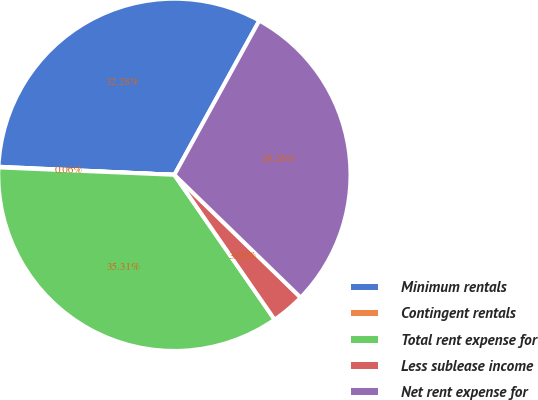<chart> <loc_0><loc_0><loc_500><loc_500><pie_chart><fcel>Minimum rentals<fcel>Contingent rentals<fcel>Total rent expense for<fcel>Less sublease income<fcel>Net rent expense for<nl><fcel>32.28%<fcel>0.06%<fcel>35.31%<fcel>3.09%<fcel>29.26%<nl></chart> 